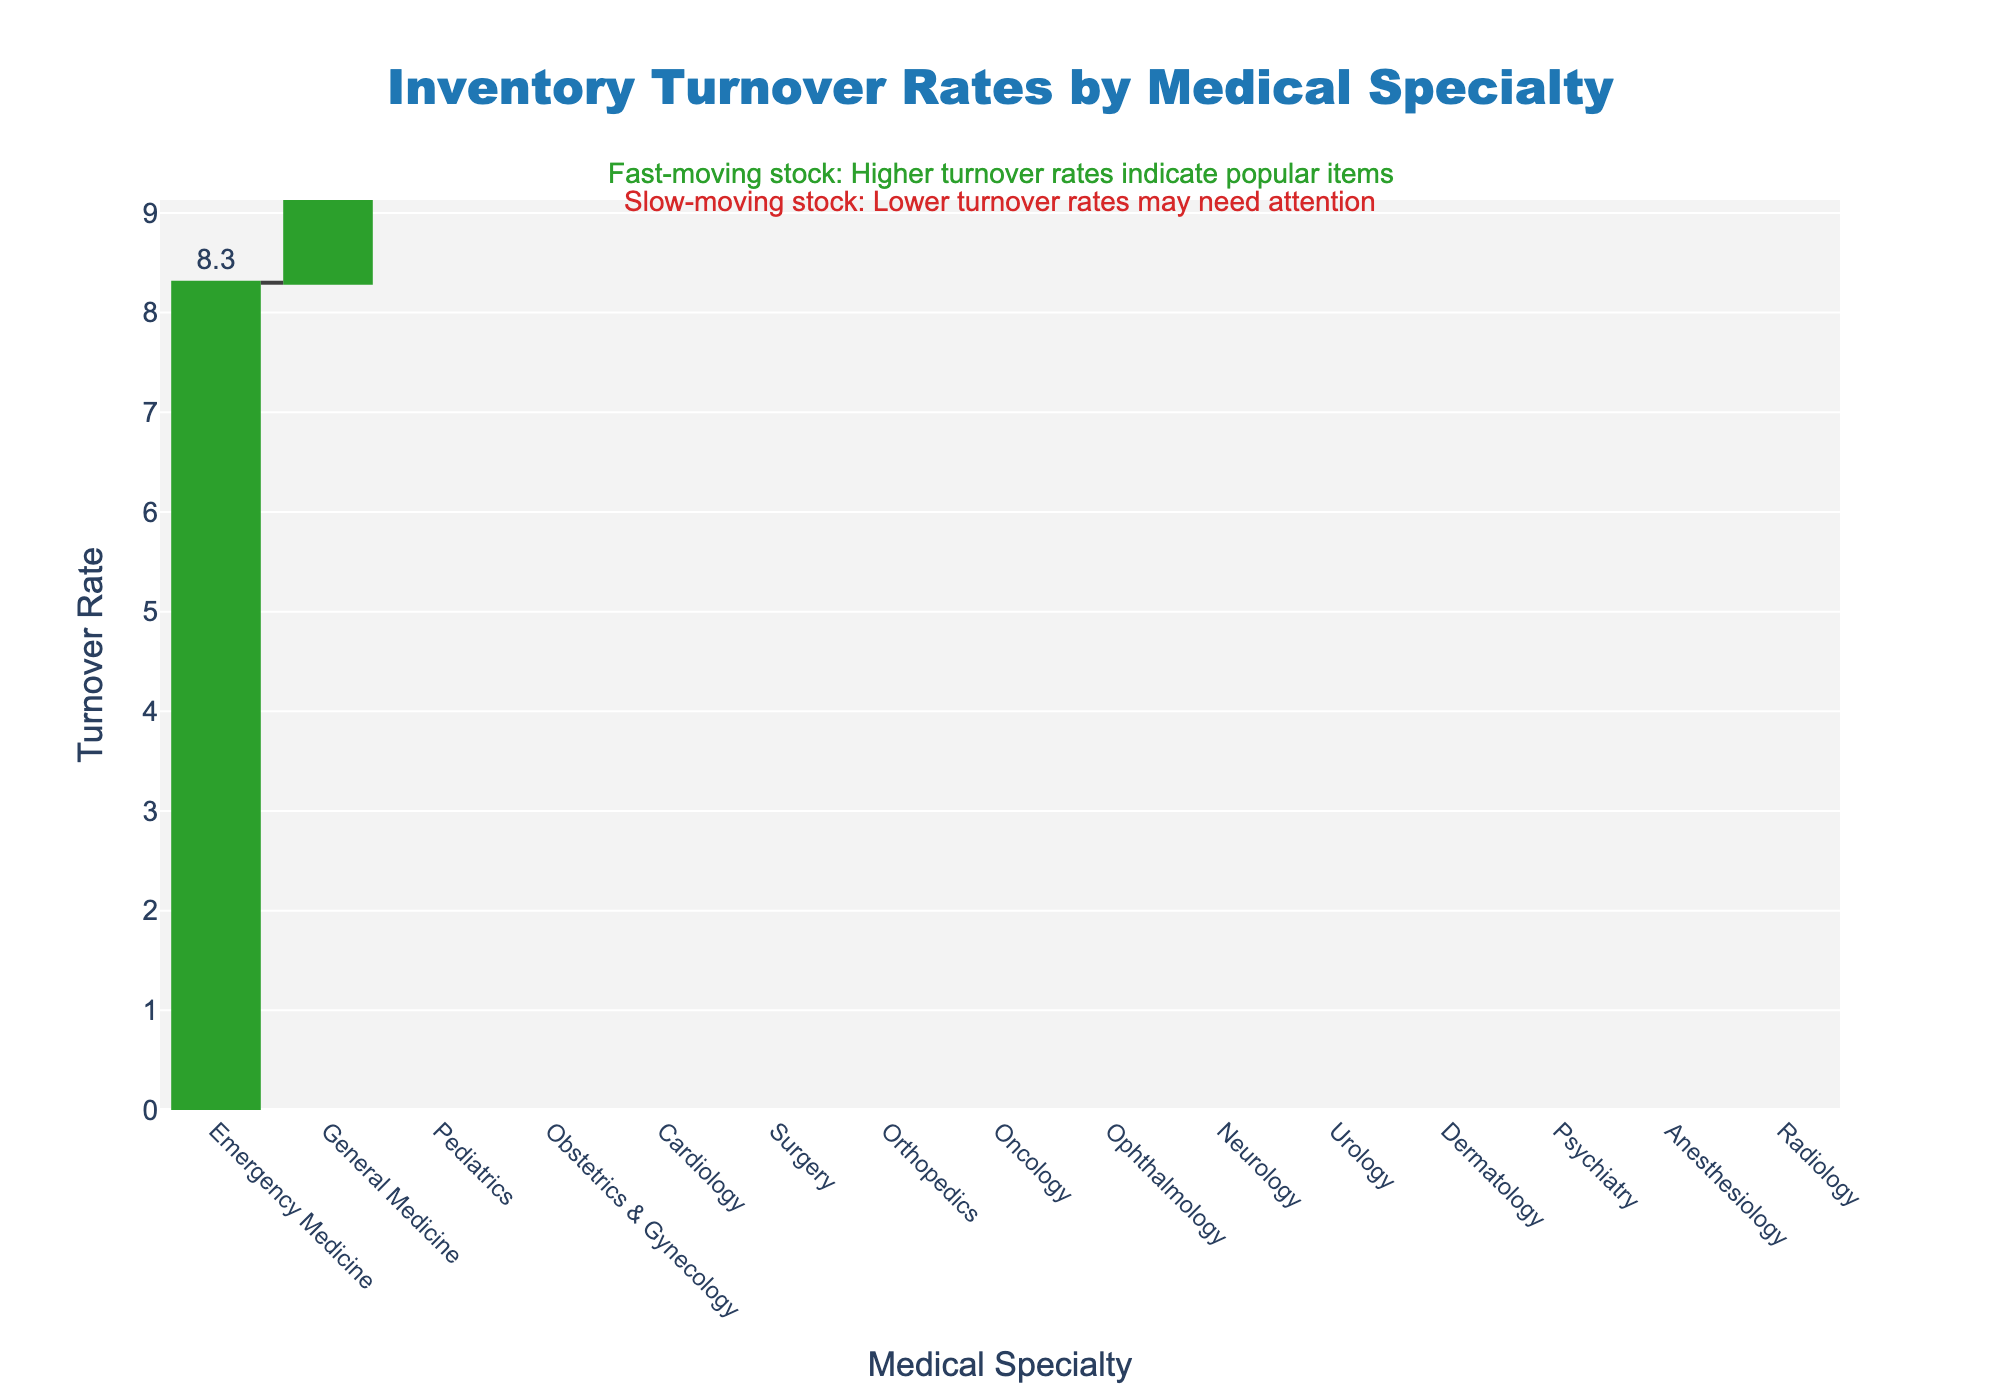What is the title of the chart? The title of the chart is usually found at the top, often centered and in a larger font than other text. The title of this chart is "Inventory Turnover Rates by Medical Specialty".
Answer: Inventory Turnover Rates by Medical Specialty Which medical specialty has the highest inventory turnover rate? To find the highest inventory turnover rate, scan the chart for the tallest bar. In this case, the bar representing Emergency Medicine is the tallest.
Answer: Emergency Medicine How many medical specialties have a turnover rate above 5? Count the bars that reach above the 5 mark on the y-axis. General Medicine (7.2), Pediatrics (6.5), Cardiology (5.6), Emergency Medicine (8.3), and Obstetrics & Gynecology (5.7) are all above 5. This gives us 5 specialties.
Answer: 5 What is the turnover rate for Dermatology compared to Neurology? Locate the bars for Dermatology and Neurology and note their heights. Dermatology has a turnover rate of 2.8, and Neurology has a rate of 3.2. Neurology is higher.
Answer: Neurology has a higher turnover rate What is the average turnover rate for Oncology, Ophthalmology, and Radiology? Add the turnover rates for Oncology (3.9), Ophthalmology (3.5), and Radiology (1.9), and then divide by the number of specialties. (3.9 + 3.5 + 1.9) / 3 = 3.1
Answer: 3.1 Which specialties have turnover rates below the average turnover rate of 4.5? Identify bars that are below the 4.5 mark on the y-axis: Oncology, Neurology, Orthopedics, Dermatology, Psychiatry, Radiology, Anesthesiology, and Urology.
Answer: Oncology, Neurology, Orthopedics, Dermatology, Psychiatry, Radiology, Anesthesiology, Urology How much higher is the turnover rate for Emergency Medicine compared to Anesthesiology? Subtract Anesthesiology's turnover rate from Emergency Medicine's. 8.3 (Emergency Medicine) - 2.2 (Anesthesiology) = 6.1
Answer: 6.1 What is the combined turnover rate for the two slowest-moving specialties? Identify the two specialties with the smallest bars: Radiology (1.9) and Psychiatry (2.5). Add their turnover rates together: 1.9 + 2.5 = 4.4
Answer: 4.4 Which specialty is closer to the median turnover rate of the dataset? First, arrange the turnover rates in order and find the middle value (or average the two middle values if there is an even number of data points). In this case, the median value is around Orthopedics (4.1).
Answer: Orthopedics How do the fast-moving stocks compare to the slow-moving stocks in this bookstore? The fast-moving stocks (e.g., Emergency Medicine, General Medicine, Pediatrics) are indicated by bars that are higher in the chart (above 6.5), while slow-moving stocks (e.g., Radiology, Psychiatry, Anesthesiology) are indicated by bars that are lower in the chart (below 3). The fast-moving stocks have much higher turnover rates.
Answer: Fast-moving stocks have higher turnover rates than slow-moving stocks 